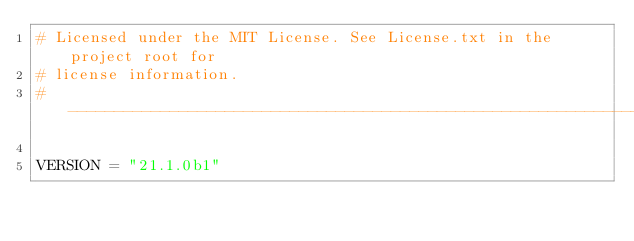<code> <loc_0><loc_0><loc_500><loc_500><_Python_># Licensed under the MIT License. See License.txt in the project root for
# license information.
# --------------------------------------------------------------------------

VERSION = "21.1.0b1"
</code> 